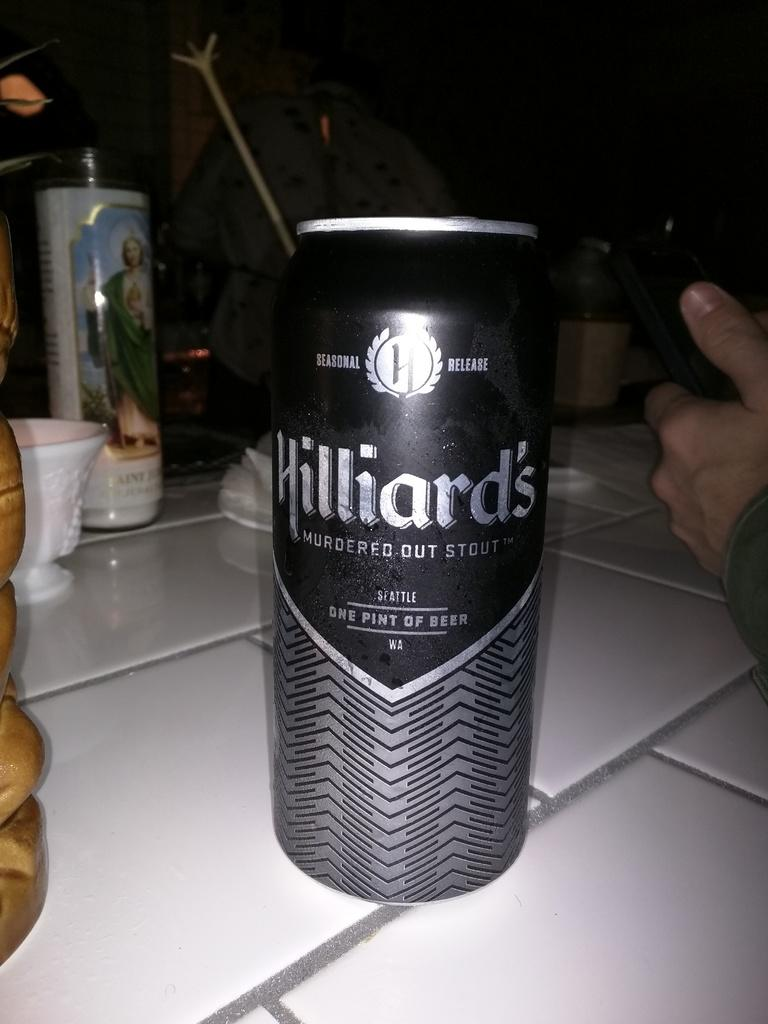Provide a one-sentence caption for the provided image. Hilliard's is a seasonal release stout from Seattle. 